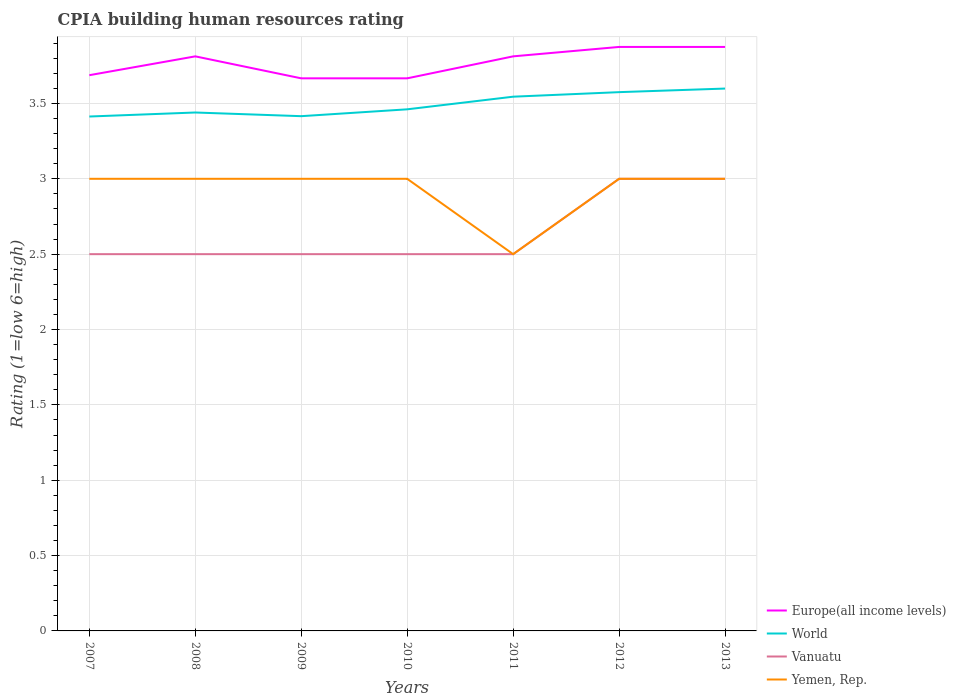Does the line corresponding to Europe(all income levels) intersect with the line corresponding to Vanuatu?
Give a very brief answer. No. Across all years, what is the maximum CPIA rating in World?
Your answer should be very brief. 3.41. In which year was the CPIA rating in Europe(all income levels) maximum?
Your answer should be very brief. 2009. What is the total CPIA rating in World in the graph?
Keep it short and to the point. -0.16. What is the difference between the highest and the second highest CPIA rating in World?
Your response must be concise. 0.19. How many years are there in the graph?
Keep it short and to the point. 7. Are the values on the major ticks of Y-axis written in scientific E-notation?
Ensure brevity in your answer.  No. Does the graph contain any zero values?
Your answer should be compact. No. Does the graph contain grids?
Keep it short and to the point. Yes. How many legend labels are there?
Provide a short and direct response. 4. How are the legend labels stacked?
Your response must be concise. Vertical. What is the title of the graph?
Provide a succinct answer. CPIA building human resources rating. Does "Gabon" appear as one of the legend labels in the graph?
Offer a very short reply. No. What is the Rating (1=low 6=high) in Europe(all income levels) in 2007?
Provide a short and direct response. 3.69. What is the Rating (1=low 6=high) of World in 2007?
Your answer should be compact. 3.41. What is the Rating (1=low 6=high) in Europe(all income levels) in 2008?
Your answer should be very brief. 3.81. What is the Rating (1=low 6=high) of World in 2008?
Provide a succinct answer. 3.44. What is the Rating (1=low 6=high) in Europe(all income levels) in 2009?
Your response must be concise. 3.67. What is the Rating (1=low 6=high) of World in 2009?
Your answer should be very brief. 3.42. What is the Rating (1=low 6=high) of Europe(all income levels) in 2010?
Offer a terse response. 3.67. What is the Rating (1=low 6=high) of World in 2010?
Keep it short and to the point. 3.46. What is the Rating (1=low 6=high) in Yemen, Rep. in 2010?
Your answer should be compact. 3. What is the Rating (1=low 6=high) in Europe(all income levels) in 2011?
Your answer should be very brief. 3.81. What is the Rating (1=low 6=high) of World in 2011?
Provide a succinct answer. 3.54. What is the Rating (1=low 6=high) in Yemen, Rep. in 2011?
Provide a short and direct response. 2.5. What is the Rating (1=low 6=high) of Europe(all income levels) in 2012?
Your answer should be compact. 3.88. What is the Rating (1=low 6=high) in World in 2012?
Make the answer very short. 3.58. What is the Rating (1=low 6=high) of Yemen, Rep. in 2012?
Provide a succinct answer. 3. What is the Rating (1=low 6=high) in Europe(all income levels) in 2013?
Provide a short and direct response. 3.88. What is the Rating (1=low 6=high) of World in 2013?
Your answer should be very brief. 3.6. What is the Rating (1=low 6=high) of Vanuatu in 2013?
Give a very brief answer. 3. Across all years, what is the maximum Rating (1=low 6=high) in Europe(all income levels)?
Ensure brevity in your answer.  3.88. Across all years, what is the maximum Rating (1=low 6=high) in World?
Ensure brevity in your answer.  3.6. Across all years, what is the minimum Rating (1=low 6=high) in Europe(all income levels)?
Ensure brevity in your answer.  3.67. Across all years, what is the minimum Rating (1=low 6=high) in World?
Your answer should be very brief. 3.41. What is the total Rating (1=low 6=high) in Europe(all income levels) in the graph?
Ensure brevity in your answer.  26.4. What is the total Rating (1=low 6=high) in World in the graph?
Make the answer very short. 24.45. What is the difference between the Rating (1=low 6=high) of Europe(all income levels) in 2007 and that in 2008?
Make the answer very short. -0.12. What is the difference between the Rating (1=low 6=high) of World in 2007 and that in 2008?
Give a very brief answer. -0.03. What is the difference between the Rating (1=low 6=high) of Vanuatu in 2007 and that in 2008?
Your answer should be very brief. 0. What is the difference between the Rating (1=low 6=high) in Europe(all income levels) in 2007 and that in 2009?
Provide a succinct answer. 0.02. What is the difference between the Rating (1=low 6=high) of World in 2007 and that in 2009?
Your response must be concise. -0. What is the difference between the Rating (1=low 6=high) of Europe(all income levels) in 2007 and that in 2010?
Provide a succinct answer. 0.02. What is the difference between the Rating (1=low 6=high) in World in 2007 and that in 2010?
Offer a terse response. -0.05. What is the difference between the Rating (1=low 6=high) in Vanuatu in 2007 and that in 2010?
Your answer should be very brief. 0. What is the difference between the Rating (1=low 6=high) of Europe(all income levels) in 2007 and that in 2011?
Offer a very short reply. -0.12. What is the difference between the Rating (1=low 6=high) in World in 2007 and that in 2011?
Provide a succinct answer. -0.13. What is the difference between the Rating (1=low 6=high) of Vanuatu in 2007 and that in 2011?
Your answer should be compact. 0. What is the difference between the Rating (1=low 6=high) in Yemen, Rep. in 2007 and that in 2011?
Your answer should be compact. 0.5. What is the difference between the Rating (1=low 6=high) in Europe(all income levels) in 2007 and that in 2012?
Make the answer very short. -0.19. What is the difference between the Rating (1=low 6=high) in World in 2007 and that in 2012?
Offer a very short reply. -0.16. What is the difference between the Rating (1=low 6=high) in Yemen, Rep. in 2007 and that in 2012?
Your answer should be very brief. 0. What is the difference between the Rating (1=low 6=high) in Europe(all income levels) in 2007 and that in 2013?
Your response must be concise. -0.19. What is the difference between the Rating (1=low 6=high) of World in 2007 and that in 2013?
Ensure brevity in your answer.  -0.19. What is the difference between the Rating (1=low 6=high) of Yemen, Rep. in 2007 and that in 2013?
Your answer should be very brief. 0. What is the difference between the Rating (1=low 6=high) in Europe(all income levels) in 2008 and that in 2009?
Ensure brevity in your answer.  0.15. What is the difference between the Rating (1=low 6=high) in World in 2008 and that in 2009?
Make the answer very short. 0.02. What is the difference between the Rating (1=low 6=high) in Vanuatu in 2008 and that in 2009?
Keep it short and to the point. 0. What is the difference between the Rating (1=low 6=high) in Yemen, Rep. in 2008 and that in 2009?
Provide a succinct answer. 0. What is the difference between the Rating (1=low 6=high) of Europe(all income levels) in 2008 and that in 2010?
Keep it short and to the point. 0.15. What is the difference between the Rating (1=low 6=high) in World in 2008 and that in 2010?
Your answer should be compact. -0.02. What is the difference between the Rating (1=low 6=high) of Vanuatu in 2008 and that in 2010?
Your answer should be compact. 0. What is the difference between the Rating (1=low 6=high) in Europe(all income levels) in 2008 and that in 2011?
Your response must be concise. 0. What is the difference between the Rating (1=low 6=high) of World in 2008 and that in 2011?
Ensure brevity in your answer.  -0.1. What is the difference between the Rating (1=low 6=high) in Vanuatu in 2008 and that in 2011?
Keep it short and to the point. 0. What is the difference between the Rating (1=low 6=high) of Europe(all income levels) in 2008 and that in 2012?
Offer a terse response. -0.06. What is the difference between the Rating (1=low 6=high) in World in 2008 and that in 2012?
Keep it short and to the point. -0.14. What is the difference between the Rating (1=low 6=high) of Vanuatu in 2008 and that in 2012?
Make the answer very short. -0.5. What is the difference between the Rating (1=low 6=high) in Yemen, Rep. in 2008 and that in 2012?
Ensure brevity in your answer.  0. What is the difference between the Rating (1=low 6=high) of Europe(all income levels) in 2008 and that in 2013?
Make the answer very short. -0.06. What is the difference between the Rating (1=low 6=high) in World in 2008 and that in 2013?
Keep it short and to the point. -0.16. What is the difference between the Rating (1=low 6=high) of Vanuatu in 2008 and that in 2013?
Your answer should be compact. -0.5. What is the difference between the Rating (1=low 6=high) in Europe(all income levels) in 2009 and that in 2010?
Your answer should be compact. 0. What is the difference between the Rating (1=low 6=high) of World in 2009 and that in 2010?
Offer a very short reply. -0.05. What is the difference between the Rating (1=low 6=high) of Yemen, Rep. in 2009 and that in 2010?
Give a very brief answer. 0. What is the difference between the Rating (1=low 6=high) of Europe(all income levels) in 2009 and that in 2011?
Provide a short and direct response. -0.15. What is the difference between the Rating (1=low 6=high) of World in 2009 and that in 2011?
Provide a short and direct response. -0.13. What is the difference between the Rating (1=low 6=high) of Vanuatu in 2009 and that in 2011?
Ensure brevity in your answer.  0. What is the difference between the Rating (1=low 6=high) in Europe(all income levels) in 2009 and that in 2012?
Your answer should be compact. -0.21. What is the difference between the Rating (1=low 6=high) in World in 2009 and that in 2012?
Your answer should be very brief. -0.16. What is the difference between the Rating (1=low 6=high) of Yemen, Rep. in 2009 and that in 2012?
Your answer should be compact. 0. What is the difference between the Rating (1=low 6=high) of Europe(all income levels) in 2009 and that in 2013?
Ensure brevity in your answer.  -0.21. What is the difference between the Rating (1=low 6=high) of World in 2009 and that in 2013?
Keep it short and to the point. -0.18. What is the difference between the Rating (1=low 6=high) in Vanuatu in 2009 and that in 2013?
Offer a very short reply. -0.5. What is the difference between the Rating (1=low 6=high) in Yemen, Rep. in 2009 and that in 2013?
Offer a terse response. 0. What is the difference between the Rating (1=low 6=high) in Europe(all income levels) in 2010 and that in 2011?
Offer a very short reply. -0.15. What is the difference between the Rating (1=low 6=high) in World in 2010 and that in 2011?
Give a very brief answer. -0.08. What is the difference between the Rating (1=low 6=high) of Vanuatu in 2010 and that in 2011?
Your response must be concise. 0. What is the difference between the Rating (1=low 6=high) in Europe(all income levels) in 2010 and that in 2012?
Your answer should be very brief. -0.21. What is the difference between the Rating (1=low 6=high) in World in 2010 and that in 2012?
Provide a short and direct response. -0.11. What is the difference between the Rating (1=low 6=high) of Europe(all income levels) in 2010 and that in 2013?
Ensure brevity in your answer.  -0.21. What is the difference between the Rating (1=low 6=high) of World in 2010 and that in 2013?
Provide a succinct answer. -0.14. What is the difference between the Rating (1=low 6=high) of Yemen, Rep. in 2010 and that in 2013?
Your response must be concise. 0. What is the difference between the Rating (1=low 6=high) of Europe(all income levels) in 2011 and that in 2012?
Provide a succinct answer. -0.06. What is the difference between the Rating (1=low 6=high) in World in 2011 and that in 2012?
Provide a short and direct response. -0.03. What is the difference between the Rating (1=low 6=high) in Vanuatu in 2011 and that in 2012?
Your answer should be very brief. -0.5. What is the difference between the Rating (1=low 6=high) in Yemen, Rep. in 2011 and that in 2012?
Keep it short and to the point. -0.5. What is the difference between the Rating (1=low 6=high) in Europe(all income levels) in 2011 and that in 2013?
Give a very brief answer. -0.06. What is the difference between the Rating (1=low 6=high) in World in 2011 and that in 2013?
Your answer should be very brief. -0.05. What is the difference between the Rating (1=low 6=high) of Vanuatu in 2011 and that in 2013?
Your answer should be very brief. -0.5. What is the difference between the Rating (1=low 6=high) in World in 2012 and that in 2013?
Make the answer very short. -0.02. What is the difference between the Rating (1=low 6=high) in Vanuatu in 2012 and that in 2013?
Your answer should be very brief. 0. What is the difference between the Rating (1=low 6=high) of Europe(all income levels) in 2007 and the Rating (1=low 6=high) of World in 2008?
Provide a succinct answer. 0.25. What is the difference between the Rating (1=low 6=high) of Europe(all income levels) in 2007 and the Rating (1=low 6=high) of Vanuatu in 2008?
Offer a terse response. 1.19. What is the difference between the Rating (1=low 6=high) of Europe(all income levels) in 2007 and the Rating (1=low 6=high) of Yemen, Rep. in 2008?
Offer a very short reply. 0.69. What is the difference between the Rating (1=low 6=high) in World in 2007 and the Rating (1=low 6=high) in Vanuatu in 2008?
Your answer should be very brief. 0.91. What is the difference between the Rating (1=low 6=high) in World in 2007 and the Rating (1=low 6=high) in Yemen, Rep. in 2008?
Ensure brevity in your answer.  0.41. What is the difference between the Rating (1=low 6=high) in Vanuatu in 2007 and the Rating (1=low 6=high) in Yemen, Rep. in 2008?
Offer a terse response. -0.5. What is the difference between the Rating (1=low 6=high) in Europe(all income levels) in 2007 and the Rating (1=low 6=high) in World in 2009?
Provide a short and direct response. 0.27. What is the difference between the Rating (1=low 6=high) of Europe(all income levels) in 2007 and the Rating (1=low 6=high) of Vanuatu in 2009?
Offer a terse response. 1.19. What is the difference between the Rating (1=low 6=high) of Europe(all income levels) in 2007 and the Rating (1=low 6=high) of Yemen, Rep. in 2009?
Your response must be concise. 0.69. What is the difference between the Rating (1=low 6=high) of World in 2007 and the Rating (1=low 6=high) of Vanuatu in 2009?
Offer a terse response. 0.91. What is the difference between the Rating (1=low 6=high) of World in 2007 and the Rating (1=low 6=high) of Yemen, Rep. in 2009?
Ensure brevity in your answer.  0.41. What is the difference between the Rating (1=low 6=high) of Vanuatu in 2007 and the Rating (1=low 6=high) of Yemen, Rep. in 2009?
Offer a terse response. -0.5. What is the difference between the Rating (1=low 6=high) in Europe(all income levels) in 2007 and the Rating (1=low 6=high) in World in 2010?
Provide a succinct answer. 0.23. What is the difference between the Rating (1=low 6=high) of Europe(all income levels) in 2007 and the Rating (1=low 6=high) of Vanuatu in 2010?
Your answer should be compact. 1.19. What is the difference between the Rating (1=low 6=high) of Europe(all income levels) in 2007 and the Rating (1=low 6=high) of Yemen, Rep. in 2010?
Your response must be concise. 0.69. What is the difference between the Rating (1=low 6=high) of World in 2007 and the Rating (1=low 6=high) of Vanuatu in 2010?
Provide a short and direct response. 0.91. What is the difference between the Rating (1=low 6=high) in World in 2007 and the Rating (1=low 6=high) in Yemen, Rep. in 2010?
Your answer should be compact. 0.41. What is the difference between the Rating (1=low 6=high) of Europe(all income levels) in 2007 and the Rating (1=low 6=high) of World in 2011?
Give a very brief answer. 0.14. What is the difference between the Rating (1=low 6=high) of Europe(all income levels) in 2007 and the Rating (1=low 6=high) of Vanuatu in 2011?
Your response must be concise. 1.19. What is the difference between the Rating (1=low 6=high) of Europe(all income levels) in 2007 and the Rating (1=low 6=high) of Yemen, Rep. in 2011?
Offer a very short reply. 1.19. What is the difference between the Rating (1=low 6=high) in World in 2007 and the Rating (1=low 6=high) in Vanuatu in 2011?
Give a very brief answer. 0.91. What is the difference between the Rating (1=low 6=high) in World in 2007 and the Rating (1=low 6=high) in Yemen, Rep. in 2011?
Provide a short and direct response. 0.91. What is the difference between the Rating (1=low 6=high) of Vanuatu in 2007 and the Rating (1=low 6=high) of Yemen, Rep. in 2011?
Your response must be concise. 0. What is the difference between the Rating (1=low 6=high) of Europe(all income levels) in 2007 and the Rating (1=low 6=high) of World in 2012?
Make the answer very short. 0.11. What is the difference between the Rating (1=low 6=high) of Europe(all income levels) in 2007 and the Rating (1=low 6=high) of Vanuatu in 2012?
Give a very brief answer. 0.69. What is the difference between the Rating (1=low 6=high) of Europe(all income levels) in 2007 and the Rating (1=low 6=high) of Yemen, Rep. in 2012?
Offer a terse response. 0.69. What is the difference between the Rating (1=low 6=high) of World in 2007 and the Rating (1=low 6=high) of Vanuatu in 2012?
Your answer should be compact. 0.41. What is the difference between the Rating (1=low 6=high) in World in 2007 and the Rating (1=low 6=high) in Yemen, Rep. in 2012?
Your answer should be compact. 0.41. What is the difference between the Rating (1=low 6=high) of Vanuatu in 2007 and the Rating (1=low 6=high) of Yemen, Rep. in 2012?
Offer a terse response. -0.5. What is the difference between the Rating (1=low 6=high) in Europe(all income levels) in 2007 and the Rating (1=low 6=high) in World in 2013?
Your answer should be very brief. 0.09. What is the difference between the Rating (1=low 6=high) in Europe(all income levels) in 2007 and the Rating (1=low 6=high) in Vanuatu in 2013?
Your answer should be very brief. 0.69. What is the difference between the Rating (1=low 6=high) of Europe(all income levels) in 2007 and the Rating (1=low 6=high) of Yemen, Rep. in 2013?
Your response must be concise. 0.69. What is the difference between the Rating (1=low 6=high) of World in 2007 and the Rating (1=low 6=high) of Vanuatu in 2013?
Your answer should be very brief. 0.41. What is the difference between the Rating (1=low 6=high) in World in 2007 and the Rating (1=low 6=high) in Yemen, Rep. in 2013?
Give a very brief answer. 0.41. What is the difference between the Rating (1=low 6=high) in Europe(all income levels) in 2008 and the Rating (1=low 6=high) in World in 2009?
Your answer should be very brief. 0.4. What is the difference between the Rating (1=low 6=high) in Europe(all income levels) in 2008 and the Rating (1=low 6=high) in Vanuatu in 2009?
Give a very brief answer. 1.31. What is the difference between the Rating (1=low 6=high) of Europe(all income levels) in 2008 and the Rating (1=low 6=high) of Yemen, Rep. in 2009?
Keep it short and to the point. 0.81. What is the difference between the Rating (1=low 6=high) in World in 2008 and the Rating (1=low 6=high) in Vanuatu in 2009?
Your answer should be very brief. 0.94. What is the difference between the Rating (1=low 6=high) of World in 2008 and the Rating (1=low 6=high) of Yemen, Rep. in 2009?
Give a very brief answer. 0.44. What is the difference between the Rating (1=low 6=high) of Europe(all income levels) in 2008 and the Rating (1=low 6=high) of World in 2010?
Offer a terse response. 0.35. What is the difference between the Rating (1=low 6=high) in Europe(all income levels) in 2008 and the Rating (1=low 6=high) in Vanuatu in 2010?
Your response must be concise. 1.31. What is the difference between the Rating (1=low 6=high) in Europe(all income levels) in 2008 and the Rating (1=low 6=high) in Yemen, Rep. in 2010?
Keep it short and to the point. 0.81. What is the difference between the Rating (1=low 6=high) of World in 2008 and the Rating (1=low 6=high) of Vanuatu in 2010?
Provide a succinct answer. 0.94. What is the difference between the Rating (1=low 6=high) of World in 2008 and the Rating (1=low 6=high) of Yemen, Rep. in 2010?
Offer a very short reply. 0.44. What is the difference between the Rating (1=low 6=high) of Europe(all income levels) in 2008 and the Rating (1=low 6=high) of World in 2011?
Ensure brevity in your answer.  0.27. What is the difference between the Rating (1=low 6=high) in Europe(all income levels) in 2008 and the Rating (1=low 6=high) in Vanuatu in 2011?
Keep it short and to the point. 1.31. What is the difference between the Rating (1=low 6=high) in Europe(all income levels) in 2008 and the Rating (1=low 6=high) in Yemen, Rep. in 2011?
Give a very brief answer. 1.31. What is the difference between the Rating (1=low 6=high) in Europe(all income levels) in 2008 and the Rating (1=low 6=high) in World in 2012?
Ensure brevity in your answer.  0.24. What is the difference between the Rating (1=low 6=high) of Europe(all income levels) in 2008 and the Rating (1=low 6=high) of Vanuatu in 2012?
Make the answer very short. 0.81. What is the difference between the Rating (1=low 6=high) in Europe(all income levels) in 2008 and the Rating (1=low 6=high) in Yemen, Rep. in 2012?
Offer a terse response. 0.81. What is the difference between the Rating (1=low 6=high) in World in 2008 and the Rating (1=low 6=high) in Vanuatu in 2012?
Your response must be concise. 0.44. What is the difference between the Rating (1=low 6=high) of World in 2008 and the Rating (1=low 6=high) of Yemen, Rep. in 2012?
Your answer should be very brief. 0.44. What is the difference between the Rating (1=low 6=high) of Europe(all income levels) in 2008 and the Rating (1=low 6=high) of World in 2013?
Make the answer very short. 0.21. What is the difference between the Rating (1=low 6=high) of Europe(all income levels) in 2008 and the Rating (1=low 6=high) of Vanuatu in 2013?
Give a very brief answer. 0.81. What is the difference between the Rating (1=low 6=high) of Europe(all income levels) in 2008 and the Rating (1=low 6=high) of Yemen, Rep. in 2013?
Offer a very short reply. 0.81. What is the difference between the Rating (1=low 6=high) in World in 2008 and the Rating (1=low 6=high) in Vanuatu in 2013?
Ensure brevity in your answer.  0.44. What is the difference between the Rating (1=low 6=high) of World in 2008 and the Rating (1=low 6=high) of Yemen, Rep. in 2013?
Keep it short and to the point. 0.44. What is the difference between the Rating (1=low 6=high) in Vanuatu in 2008 and the Rating (1=low 6=high) in Yemen, Rep. in 2013?
Give a very brief answer. -0.5. What is the difference between the Rating (1=low 6=high) in Europe(all income levels) in 2009 and the Rating (1=low 6=high) in World in 2010?
Offer a terse response. 0.21. What is the difference between the Rating (1=low 6=high) in Europe(all income levels) in 2009 and the Rating (1=low 6=high) in Yemen, Rep. in 2010?
Keep it short and to the point. 0.67. What is the difference between the Rating (1=low 6=high) of World in 2009 and the Rating (1=low 6=high) of Vanuatu in 2010?
Make the answer very short. 0.92. What is the difference between the Rating (1=low 6=high) in World in 2009 and the Rating (1=low 6=high) in Yemen, Rep. in 2010?
Provide a succinct answer. 0.42. What is the difference between the Rating (1=low 6=high) of Europe(all income levels) in 2009 and the Rating (1=low 6=high) of World in 2011?
Give a very brief answer. 0.12. What is the difference between the Rating (1=low 6=high) in Europe(all income levels) in 2009 and the Rating (1=low 6=high) in Vanuatu in 2011?
Your answer should be compact. 1.17. What is the difference between the Rating (1=low 6=high) of World in 2009 and the Rating (1=low 6=high) of Vanuatu in 2011?
Offer a terse response. 0.92. What is the difference between the Rating (1=low 6=high) in World in 2009 and the Rating (1=low 6=high) in Yemen, Rep. in 2011?
Provide a succinct answer. 0.92. What is the difference between the Rating (1=low 6=high) in Vanuatu in 2009 and the Rating (1=low 6=high) in Yemen, Rep. in 2011?
Provide a short and direct response. 0. What is the difference between the Rating (1=low 6=high) of Europe(all income levels) in 2009 and the Rating (1=low 6=high) of World in 2012?
Provide a succinct answer. 0.09. What is the difference between the Rating (1=low 6=high) in Europe(all income levels) in 2009 and the Rating (1=low 6=high) in Yemen, Rep. in 2012?
Offer a very short reply. 0.67. What is the difference between the Rating (1=low 6=high) of World in 2009 and the Rating (1=low 6=high) of Vanuatu in 2012?
Offer a very short reply. 0.42. What is the difference between the Rating (1=low 6=high) of World in 2009 and the Rating (1=low 6=high) of Yemen, Rep. in 2012?
Your answer should be compact. 0.42. What is the difference between the Rating (1=low 6=high) of Vanuatu in 2009 and the Rating (1=low 6=high) of Yemen, Rep. in 2012?
Provide a succinct answer. -0.5. What is the difference between the Rating (1=low 6=high) of Europe(all income levels) in 2009 and the Rating (1=low 6=high) of World in 2013?
Your answer should be very brief. 0.07. What is the difference between the Rating (1=low 6=high) in Europe(all income levels) in 2009 and the Rating (1=low 6=high) in Vanuatu in 2013?
Give a very brief answer. 0.67. What is the difference between the Rating (1=low 6=high) of Europe(all income levels) in 2009 and the Rating (1=low 6=high) of Yemen, Rep. in 2013?
Make the answer very short. 0.67. What is the difference between the Rating (1=low 6=high) in World in 2009 and the Rating (1=low 6=high) in Vanuatu in 2013?
Provide a short and direct response. 0.42. What is the difference between the Rating (1=low 6=high) of World in 2009 and the Rating (1=low 6=high) of Yemen, Rep. in 2013?
Your answer should be very brief. 0.42. What is the difference between the Rating (1=low 6=high) in Europe(all income levels) in 2010 and the Rating (1=low 6=high) in World in 2011?
Your response must be concise. 0.12. What is the difference between the Rating (1=low 6=high) of Europe(all income levels) in 2010 and the Rating (1=low 6=high) of Yemen, Rep. in 2011?
Your answer should be very brief. 1.17. What is the difference between the Rating (1=low 6=high) in World in 2010 and the Rating (1=low 6=high) in Yemen, Rep. in 2011?
Keep it short and to the point. 0.96. What is the difference between the Rating (1=low 6=high) of Europe(all income levels) in 2010 and the Rating (1=low 6=high) of World in 2012?
Keep it short and to the point. 0.09. What is the difference between the Rating (1=low 6=high) in World in 2010 and the Rating (1=low 6=high) in Vanuatu in 2012?
Give a very brief answer. 0.46. What is the difference between the Rating (1=low 6=high) of World in 2010 and the Rating (1=low 6=high) of Yemen, Rep. in 2012?
Provide a short and direct response. 0.46. What is the difference between the Rating (1=low 6=high) of Vanuatu in 2010 and the Rating (1=low 6=high) of Yemen, Rep. in 2012?
Offer a terse response. -0.5. What is the difference between the Rating (1=low 6=high) of Europe(all income levels) in 2010 and the Rating (1=low 6=high) of World in 2013?
Your answer should be compact. 0.07. What is the difference between the Rating (1=low 6=high) in World in 2010 and the Rating (1=low 6=high) in Vanuatu in 2013?
Offer a terse response. 0.46. What is the difference between the Rating (1=low 6=high) of World in 2010 and the Rating (1=low 6=high) of Yemen, Rep. in 2013?
Provide a short and direct response. 0.46. What is the difference between the Rating (1=low 6=high) in Vanuatu in 2010 and the Rating (1=low 6=high) in Yemen, Rep. in 2013?
Provide a short and direct response. -0.5. What is the difference between the Rating (1=low 6=high) in Europe(all income levels) in 2011 and the Rating (1=low 6=high) in World in 2012?
Ensure brevity in your answer.  0.24. What is the difference between the Rating (1=low 6=high) in Europe(all income levels) in 2011 and the Rating (1=low 6=high) in Vanuatu in 2012?
Your answer should be very brief. 0.81. What is the difference between the Rating (1=low 6=high) of Europe(all income levels) in 2011 and the Rating (1=low 6=high) of Yemen, Rep. in 2012?
Offer a very short reply. 0.81. What is the difference between the Rating (1=low 6=high) in World in 2011 and the Rating (1=low 6=high) in Vanuatu in 2012?
Ensure brevity in your answer.  0.54. What is the difference between the Rating (1=low 6=high) in World in 2011 and the Rating (1=low 6=high) in Yemen, Rep. in 2012?
Your answer should be very brief. 0.54. What is the difference between the Rating (1=low 6=high) of Europe(all income levels) in 2011 and the Rating (1=low 6=high) of World in 2013?
Your answer should be compact. 0.21. What is the difference between the Rating (1=low 6=high) of Europe(all income levels) in 2011 and the Rating (1=low 6=high) of Vanuatu in 2013?
Your response must be concise. 0.81. What is the difference between the Rating (1=low 6=high) in Europe(all income levels) in 2011 and the Rating (1=low 6=high) in Yemen, Rep. in 2013?
Give a very brief answer. 0.81. What is the difference between the Rating (1=low 6=high) of World in 2011 and the Rating (1=low 6=high) of Vanuatu in 2013?
Give a very brief answer. 0.54. What is the difference between the Rating (1=low 6=high) of World in 2011 and the Rating (1=low 6=high) of Yemen, Rep. in 2013?
Make the answer very short. 0.54. What is the difference between the Rating (1=low 6=high) of Europe(all income levels) in 2012 and the Rating (1=low 6=high) of World in 2013?
Give a very brief answer. 0.28. What is the difference between the Rating (1=low 6=high) in Europe(all income levels) in 2012 and the Rating (1=low 6=high) in Vanuatu in 2013?
Your answer should be very brief. 0.88. What is the difference between the Rating (1=low 6=high) of Europe(all income levels) in 2012 and the Rating (1=low 6=high) of Yemen, Rep. in 2013?
Give a very brief answer. 0.88. What is the difference between the Rating (1=low 6=high) in World in 2012 and the Rating (1=low 6=high) in Vanuatu in 2013?
Your answer should be compact. 0.57. What is the difference between the Rating (1=low 6=high) in World in 2012 and the Rating (1=low 6=high) in Yemen, Rep. in 2013?
Keep it short and to the point. 0.57. What is the average Rating (1=low 6=high) in Europe(all income levels) per year?
Your answer should be very brief. 3.77. What is the average Rating (1=low 6=high) in World per year?
Make the answer very short. 3.49. What is the average Rating (1=low 6=high) of Vanuatu per year?
Give a very brief answer. 2.64. What is the average Rating (1=low 6=high) of Yemen, Rep. per year?
Ensure brevity in your answer.  2.93. In the year 2007, what is the difference between the Rating (1=low 6=high) in Europe(all income levels) and Rating (1=low 6=high) in World?
Provide a succinct answer. 0.27. In the year 2007, what is the difference between the Rating (1=low 6=high) in Europe(all income levels) and Rating (1=low 6=high) in Vanuatu?
Make the answer very short. 1.19. In the year 2007, what is the difference between the Rating (1=low 6=high) of Europe(all income levels) and Rating (1=low 6=high) of Yemen, Rep.?
Offer a very short reply. 0.69. In the year 2007, what is the difference between the Rating (1=low 6=high) of World and Rating (1=low 6=high) of Vanuatu?
Your answer should be very brief. 0.91. In the year 2007, what is the difference between the Rating (1=low 6=high) of World and Rating (1=low 6=high) of Yemen, Rep.?
Provide a short and direct response. 0.41. In the year 2007, what is the difference between the Rating (1=low 6=high) of Vanuatu and Rating (1=low 6=high) of Yemen, Rep.?
Keep it short and to the point. -0.5. In the year 2008, what is the difference between the Rating (1=low 6=high) in Europe(all income levels) and Rating (1=low 6=high) in World?
Keep it short and to the point. 0.37. In the year 2008, what is the difference between the Rating (1=low 6=high) in Europe(all income levels) and Rating (1=low 6=high) in Vanuatu?
Your response must be concise. 1.31. In the year 2008, what is the difference between the Rating (1=low 6=high) in Europe(all income levels) and Rating (1=low 6=high) in Yemen, Rep.?
Your answer should be very brief. 0.81. In the year 2008, what is the difference between the Rating (1=low 6=high) in World and Rating (1=low 6=high) in Yemen, Rep.?
Your response must be concise. 0.44. In the year 2009, what is the difference between the Rating (1=low 6=high) of Europe(all income levels) and Rating (1=low 6=high) of World?
Provide a short and direct response. 0.25. In the year 2009, what is the difference between the Rating (1=low 6=high) in Europe(all income levels) and Rating (1=low 6=high) in Yemen, Rep.?
Provide a succinct answer. 0.67. In the year 2009, what is the difference between the Rating (1=low 6=high) of World and Rating (1=low 6=high) of Vanuatu?
Your response must be concise. 0.92. In the year 2009, what is the difference between the Rating (1=low 6=high) of World and Rating (1=low 6=high) of Yemen, Rep.?
Offer a very short reply. 0.42. In the year 2009, what is the difference between the Rating (1=low 6=high) in Vanuatu and Rating (1=low 6=high) in Yemen, Rep.?
Provide a succinct answer. -0.5. In the year 2010, what is the difference between the Rating (1=low 6=high) of Europe(all income levels) and Rating (1=low 6=high) of World?
Ensure brevity in your answer.  0.21. In the year 2010, what is the difference between the Rating (1=low 6=high) of Europe(all income levels) and Rating (1=low 6=high) of Yemen, Rep.?
Your answer should be compact. 0.67. In the year 2010, what is the difference between the Rating (1=low 6=high) in World and Rating (1=low 6=high) in Yemen, Rep.?
Provide a short and direct response. 0.46. In the year 2010, what is the difference between the Rating (1=low 6=high) in Vanuatu and Rating (1=low 6=high) in Yemen, Rep.?
Give a very brief answer. -0.5. In the year 2011, what is the difference between the Rating (1=low 6=high) of Europe(all income levels) and Rating (1=low 6=high) of World?
Provide a succinct answer. 0.27. In the year 2011, what is the difference between the Rating (1=low 6=high) in Europe(all income levels) and Rating (1=low 6=high) in Vanuatu?
Ensure brevity in your answer.  1.31. In the year 2011, what is the difference between the Rating (1=low 6=high) in Europe(all income levels) and Rating (1=low 6=high) in Yemen, Rep.?
Ensure brevity in your answer.  1.31. In the year 2011, what is the difference between the Rating (1=low 6=high) in World and Rating (1=low 6=high) in Vanuatu?
Offer a terse response. 1.04. In the year 2011, what is the difference between the Rating (1=low 6=high) of World and Rating (1=low 6=high) of Yemen, Rep.?
Your answer should be compact. 1.04. In the year 2012, what is the difference between the Rating (1=low 6=high) in Europe(all income levels) and Rating (1=low 6=high) in Yemen, Rep.?
Provide a succinct answer. 0.88. In the year 2012, what is the difference between the Rating (1=low 6=high) of World and Rating (1=low 6=high) of Vanuatu?
Ensure brevity in your answer.  0.57. In the year 2012, what is the difference between the Rating (1=low 6=high) in World and Rating (1=low 6=high) in Yemen, Rep.?
Give a very brief answer. 0.57. In the year 2013, what is the difference between the Rating (1=low 6=high) in Europe(all income levels) and Rating (1=low 6=high) in World?
Ensure brevity in your answer.  0.28. In the year 2013, what is the difference between the Rating (1=low 6=high) in Europe(all income levels) and Rating (1=low 6=high) in Vanuatu?
Provide a succinct answer. 0.88. In the year 2013, what is the difference between the Rating (1=low 6=high) in Europe(all income levels) and Rating (1=low 6=high) in Yemen, Rep.?
Provide a short and direct response. 0.88. In the year 2013, what is the difference between the Rating (1=low 6=high) of World and Rating (1=low 6=high) of Vanuatu?
Offer a terse response. 0.6. In the year 2013, what is the difference between the Rating (1=low 6=high) in World and Rating (1=low 6=high) in Yemen, Rep.?
Provide a short and direct response. 0.6. What is the ratio of the Rating (1=low 6=high) in Europe(all income levels) in 2007 to that in 2008?
Provide a short and direct response. 0.97. What is the ratio of the Rating (1=low 6=high) of World in 2007 to that in 2009?
Your response must be concise. 1. What is the ratio of the Rating (1=low 6=high) in Vanuatu in 2007 to that in 2009?
Your answer should be very brief. 1. What is the ratio of the Rating (1=low 6=high) in Europe(all income levels) in 2007 to that in 2010?
Your answer should be compact. 1.01. What is the ratio of the Rating (1=low 6=high) of World in 2007 to that in 2010?
Give a very brief answer. 0.99. What is the ratio of the Rating (1=low 6=high) in Vanuatu in 2007 to that in 2010?
Your answer should be compact. 1. What is the ratio of the Rating (1=low 6=high) of Europe(all income levels) in 2007 to that in 2011?
Your answer should be very brief. 0.97. What is the ratio of the Rating (1=low 6=high) in World in 2007 to that in 2011?
Offer a terse response. 0.96. What is the ratio of the Rating (1=low 6=high) in Vanuatu in 2007 to that in 2011?
Provide a short and direct response. 1. What is the ratio of the Rating (1=low 6=high) in Europe(all income levels) in 2007 to that in 2012?
Your response must be concise. 0.95. What is the ratio of the Rating (1=low 6=high) of World in 2007 to that in 2012?
Give a very brief answer. 0.95. What is the ratio of the Rating (1=low 6=high) in Yemen, Rep. in 2007 to that in 2012?
Offer a very short reply. 1. What is the ratio of the Rating (1=low 6=high) of Europe(all income levels) in 2007 to that in 2013?
Provide a short and direct response. 0.95. What is the ratio of the Rating (1=low 6=high) in World in 2007 to that in 2013?
Make the answer very short. 0.95. What is the ratio of the Rating (1=low 6=high) of Vanuatu in 2007 to that in 2013?
Offer a very short reply. 0.83. What is the ratio of the Rating (1=low 6=high) in Europe(all income levels) in 2008 to that in 2009?
Your response must be concise. 1.04. What is the ratio of the Rating (1=low 6=high) of World in 2008 to that in 2009?
Your answer should be compact. 1.01. What is the ratio of the Rating (1=low 6=high) in Europe(all income levels) in 2008 to that in 2010?
Your answer should be very brief. 1.04. What is the ratio of the Rating (1=low 6=high) in World in 2008 to that in 2010?
Provide a succinct answer. 0.99. What is the ratio of the Rating (1=low 6=high) of Yemen, Rep. in 2008 to that in 2010?
Ensure brevity in your answer.  1. What is the ratio of the Rating (1=low 6=high) in Europe(all income levels) in 2008 to that in 2011?
Ensure brevity in your answer.  1. What is the ratio of the Rating (1=low 6=high) in World in 2008 to that in 2011?
Provide a short and direct response. 0.97. What is the ratio of the Rating (1=low 6=high) in Europe(all income levels) in 2008 to that in 2012?
Ensure brevity in your answer.  0.98. What is the ratio of the Rating (1=low 6=high) in World in 2008 to that in 2012?
Provide a short and direct response. 0.96. What is the ratio of the Rating (1=low 6=high) of Yemen, Rep. in 2008 to that in 2012?
Keep it short and to the point. 1. What is the ratio of the Rating (1=low 6=high) in Europe(all income levels) in 2008 to that in 2013?
Keep it short and to the point. 0.98. What is the ratio of the Rating (1=low 6=high) of World in 2008 to that in 2013?
Provide a short and direct response. 0.96. What is the ratio of the Rating (1=low 6=high) of Vanuatu in 2008 to that in 2013?
Provide a short and direct response. 0.83. What is the ratio of the Rating (1=low 6=high) of Europe(all income levels) in 2009 to that in 2010?
Your response must be concise. 1. What is the ratio of the Rating (1=low 6=high) in World in 2009 to that in 2010?
Offer a very short reply. 0.99. What is the ratio of the Rating (1=low 6=high) in Europe(all income levels) in 2009 to that in 2011?
Ensure brevity in your answer.  0.96. What is the ratio of the Rating (1=low 6=high) of World in 2009 to that in 2011?
Offer a terse response. 0.96. What is the ratio of the Rating (1=low 6=high) in Vanuatu in 2009 to that in 2011?
Offer a terse response. 1. What is the ratio of the Rating (1=low 6=high) of Yemen, Rep. in 2009 to that in 2011?
Ensure brevity in your answer.  1.2. What is the ratio of the Rating (1=low 6=high) in Europe(all income levels) in 2009 to that in 2012?
Give a very brief answer. 0.95. What is the ratio of the Rating (1=low 6=high) in World in 2009 to that in 2012?
Provide a short and direct response. 0.96. What is the ratio of the Rating (1=low 6=high) of Vanuatu in 2009 to that in 2012?
Offer a terse response. 0.83. What is the ratio of the Rating (1=low 6=high) in Europe(all income levels) in 2009 to that in 2013?
Offer a very short reply. 0.95. What is the ratio of the Rating (1=low 6=high) of World in 2009 to that in 2013?
Your answer should be compact. 0.95. What is the ratio of the Rating (1=low 6=high) of Vanuatu in 2009 to that in 2013?
Your answer should be compact. 0.83. What is the ratio of the Rating (1=low 6=high) of Europe(all income levels) in 2010 to that in 2011?
Offer a terse response. 0.96. What is the ratio of the Rating (1=low 6=high) in World in 2010 to that in 2011?
Give a very brief answer. 0.98. What is the ratio of the Rating (1=low 6=high) of Yemen, Rep. in 2010 to that in 2011?
Give a very brief answer. 1.2. What is the ratio of the Rating (1=low 6=high) in Europe(all income levels) in 2010 to that in 2012?
Provide a short and direct response. 0.95. What is the ratio of the Rating (1=low 6=high) in World in 2010 to that in 2012?
Ensure brevity in your answer.  0.97. What is the ratio of the Rating (1=low 6=high) in Vanuatu in 2010 to that in 2012?
Your answer should be compact. 0.83. What is the ratio of the Rating (1=low 6=high) in Yemen, Rep. in 2010 to that in 2012?
Keep it short and to the point. 1. What is the ratio of the Rating (1=low 6=high) of Europe(all income levels) in 2010 to that in 2013?
Your answer should be compact. 0.95. What is the ratio of the Rating (1=low 6=high) in World in 2010 to that in 2013?
Provide a short and direct response. 0.96. What is the ratio of the Rating (1=low 6=high) of Yemen, Rep. in 2010 to that in 2013?
Your response must be concise. 1. What is the ratio of the Rating (1=low 6=high) in Europe(all income levels) in 2011 to that in 2012?
Provide a short and direct response. 0.98. What is the ratio of the Rating (1=low 6=high) in Vanuatu in 2011 to that in 2012?
Make the answer very short. 0.83. What is the ratio of the Rating (1=low 6=high) in Europe(all income levels) in 2011 to that in 2013?
Provide a succinct answer. 0.98. What is the ratio of the Rating (1=low 6=high) of Yemen, Rep. in 2011 to that in 2013?
Ensure brevity in your answer.  0.83. What is the ratio of the Rating (1=low 6=high) in Europe(all income levels) in 2012 to that in 2013?
Keep it short and to the point. 1. What is the ratio of the Rating (1=low 6=high) in World in 2012 to that in 2013?
Your response must be concise. 0.99. What is the ratio of the Rating (1=low 6=high) in Yemen, Rep. in 2012 to that in 2013?
Offer a very short reply. 1. What is the difference between the highest and the second highest Rating (1=low 6=high) of World?
Your answer should be very brief. 0.02. What is the difference between the highest and the second highest Rating (1=low 6=high) in Vanuatu?
Provide a short and direct response. 0. What is the difference between the highest and the lowest Rating (1=low 6=high) of Europe(all income levels)?
Ensure brevity in your answer.  0.21. What is the difference between the highest and the lowest Rating (1=low 6=high) in World?
Provide a short and direct response. 0.19. What is the difference between the highest and the lowest Rating (1=low 6=high) in Yemen, Rep.?
Provide a succinct answer. 0.5. 